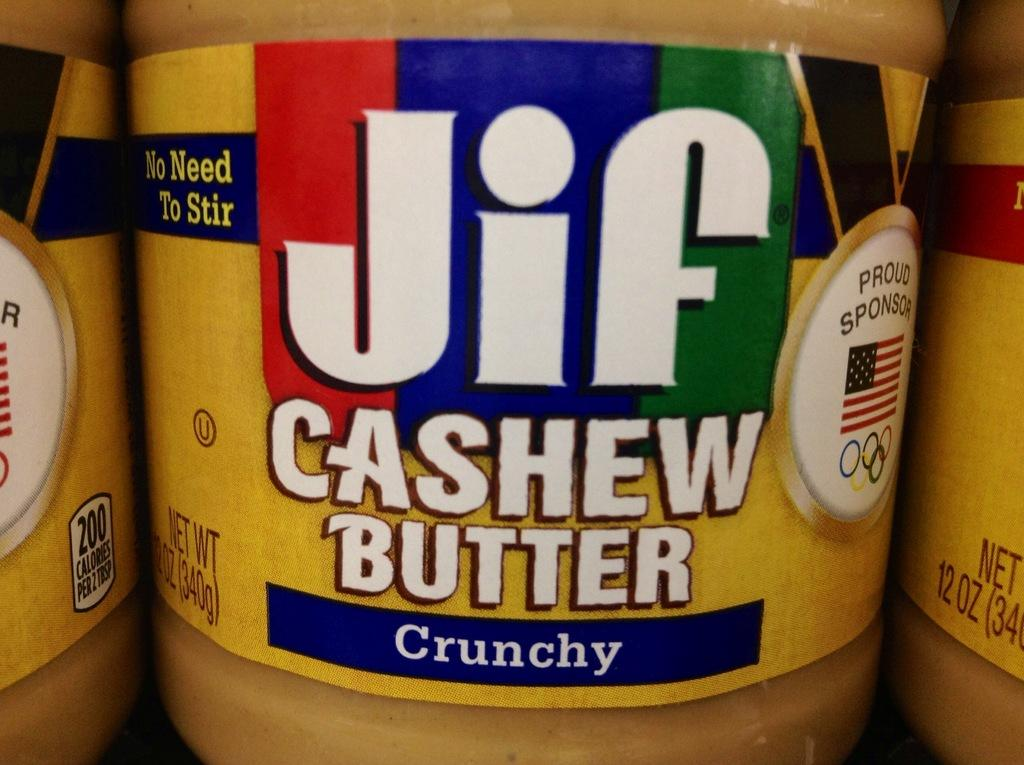<image>
Describe the image concisely. Jif Cashew peanut butter crunchy in between two other peanut butter jars. 